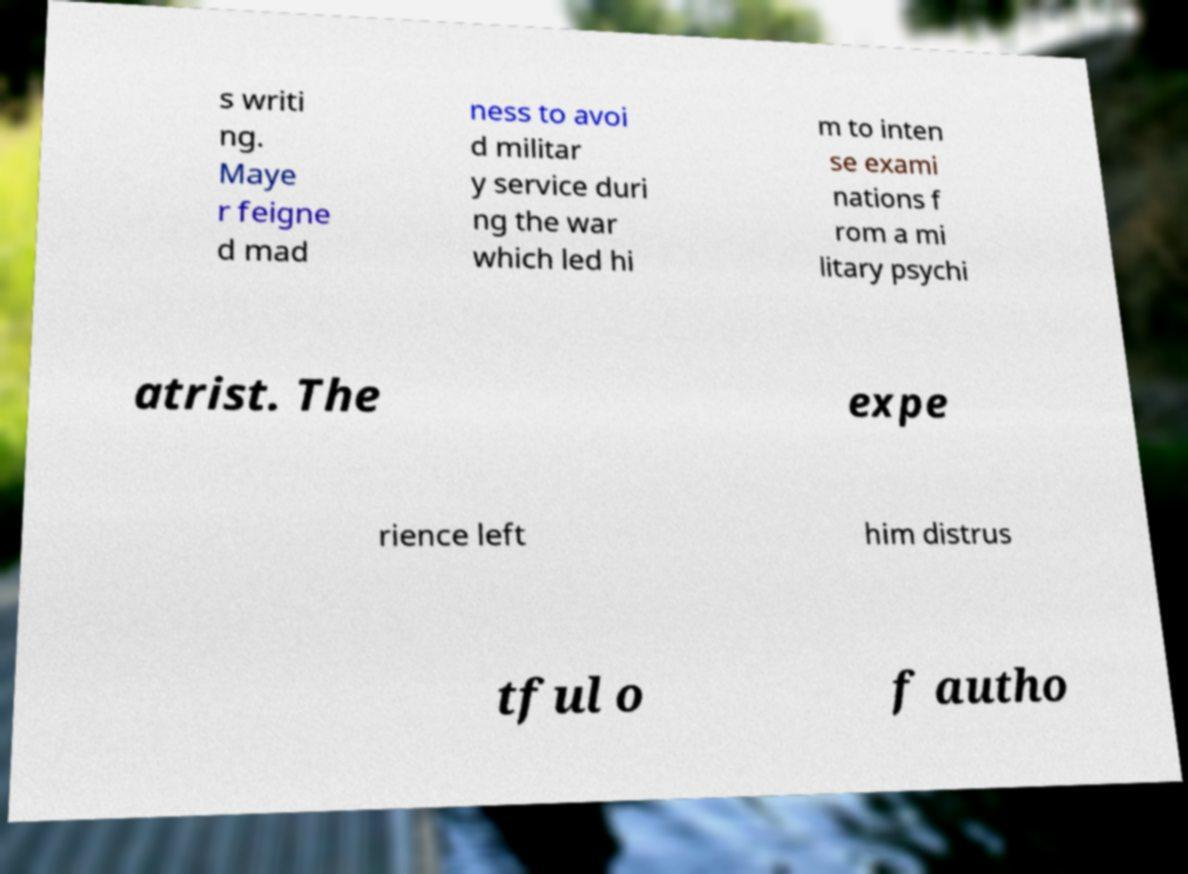Please read and relay the text visible in this image. What does it say? s writi ng. Maye r feigne d mad ness to avoi d militar y service duri ng the war which led hi m to inten se exami nations f rom a mi litary psychi atrist. The expe rience left him distrus tful o f autho 